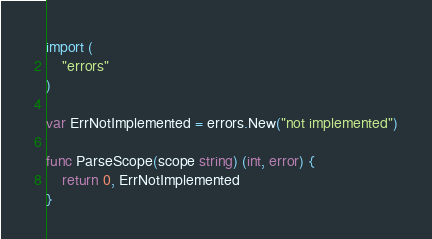<code> <loc_0><loc_0><loc_500><loc_500><_Go_>
import (
	"errors"
)

var ErrNotImplemented = errors.New("not implemented")

func ParseScope(scope string) (int, error) {
	return 0, ErrNotImplemented
}
</code> 